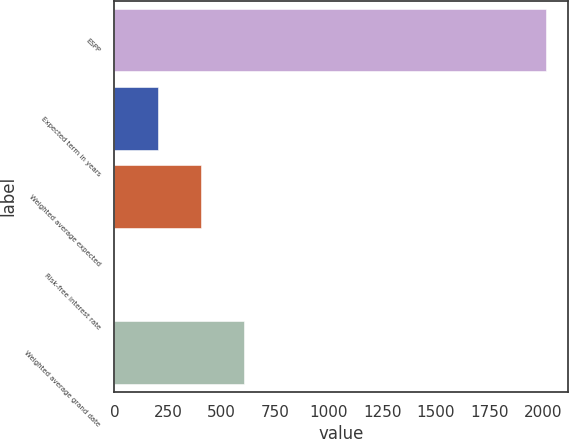<chart> <loc_0><loc_0><loc_500><loc_500><bar_chart><fcel>ESPP<fcel>Expected term in years<fcel>Weighted average expected<fcel>Risk-free interest rate<fcel>Weighted average grand date<nl><fcel>2015<fcel>201.61<fcel>403.1<fcel>0.12<fcel>604.59<nl></chart> 